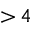Convert formula to latex. <formula><loc_0><loc_0><loc_500><loc_500>{ > } \, 4</formula> 